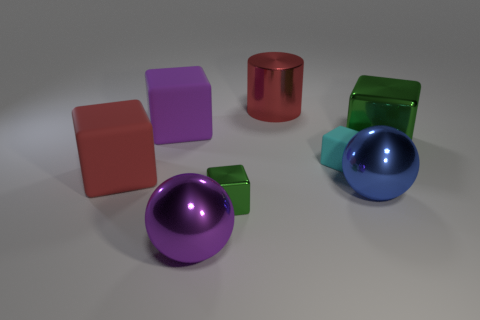Subtract all small green metal blocks. How many blocks are left? 4 Add 2 big cylinders. How many objects exist? 10 Subtract all blue balls. How many green cubes are left? 2 Subtract all green blocks. How many blocks are left? 3 Subtract all cubes. How many objects are left? 3 Subtract 1 balls. How many balls are left? 1 Add 1 large red rubber things. How many large red rubber things are left? 2 Add 4 small shiny blocks. How many small shiny blocks exist? 5 Subtract 0 green cylinders. How many objects are left? 8 Subtract all purple balls. Subtract all red cylinders. How many balls are left? 1 